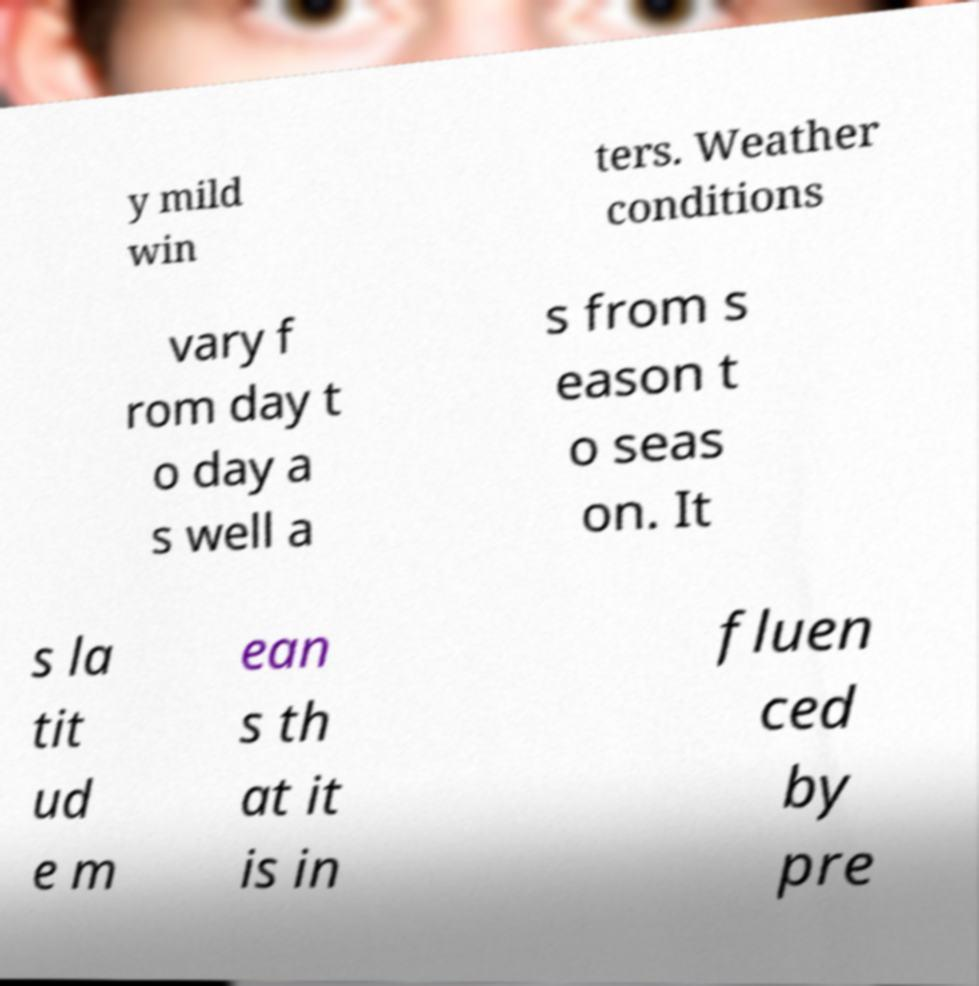I need the written content from this picture converted into text. Can you do that? y mild win ters. Weather conditions vary f rom day t o day a s well a s from s eason t o seas on. It s la tit ud e m ean s th at it is in fluen ced by pre 